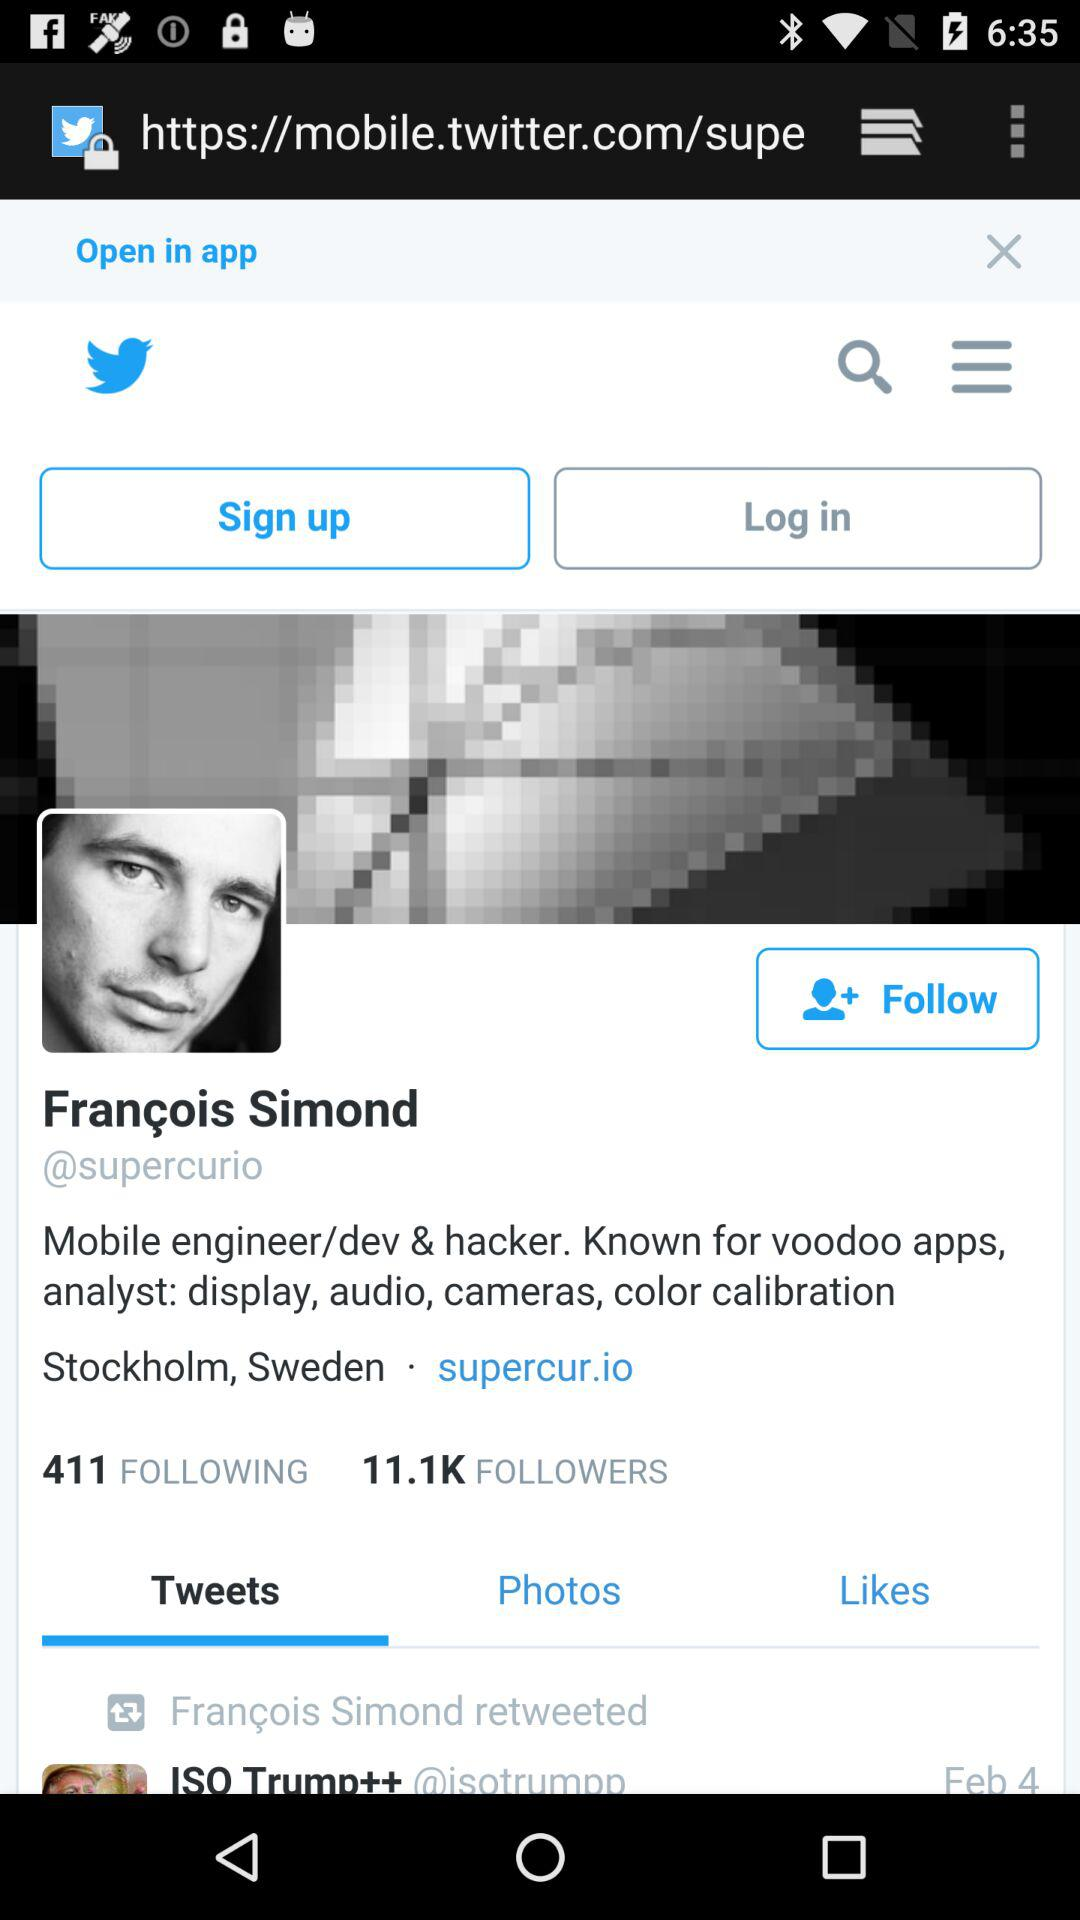What is the application name? The application name is "twitter". 